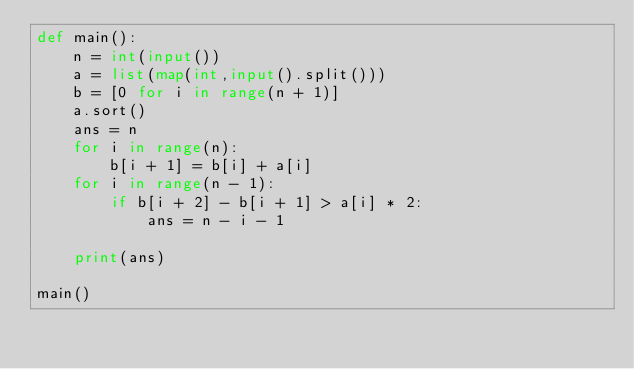Convert code to text. <code><loc_0><loc_0><loc_500><loc_500><_Python_>def main():
    n = int(input())
    a = list(map(int,input().split()))
    b = [0 for i in range(n + 1)]
    a.sort()
    ans = n
    for i in range(n):
        b[i + 1] = b[i] + a[i]
    for i in range(n - 1):
        if b[i + 2] - b[i + 1] > a[i] * 2:
            ans = n - i - 1

    print(ans)

main()</code> 